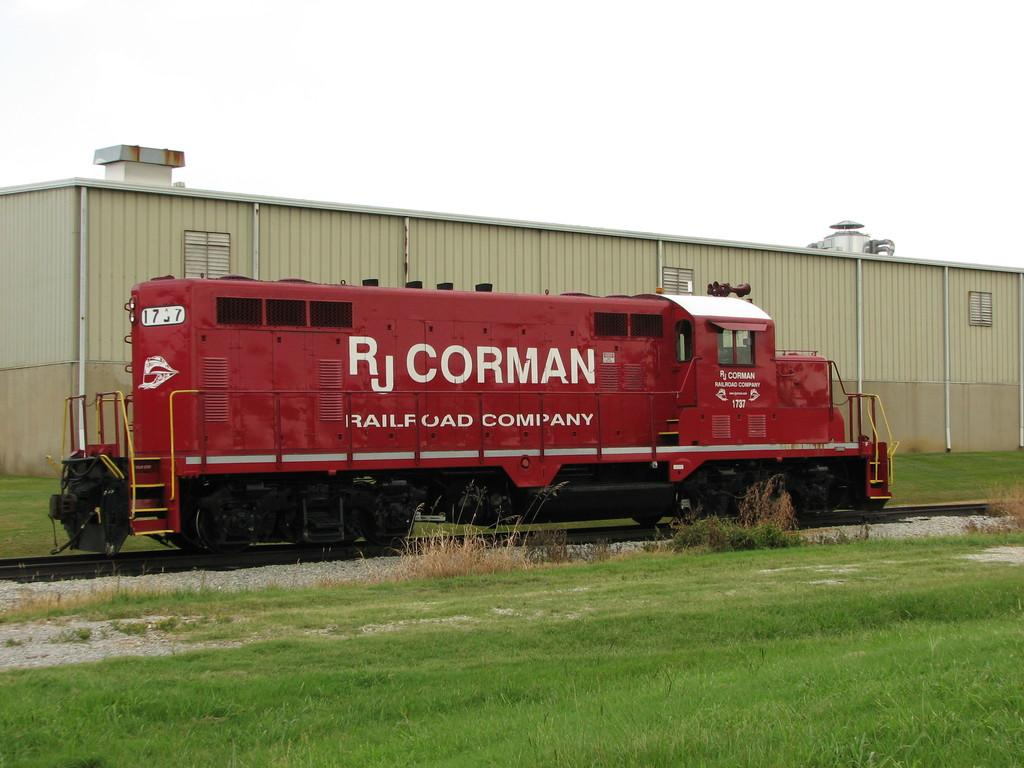<image>
Provide a brief description of the given image. A train is labelled "RJ Corman Railroad Company." 